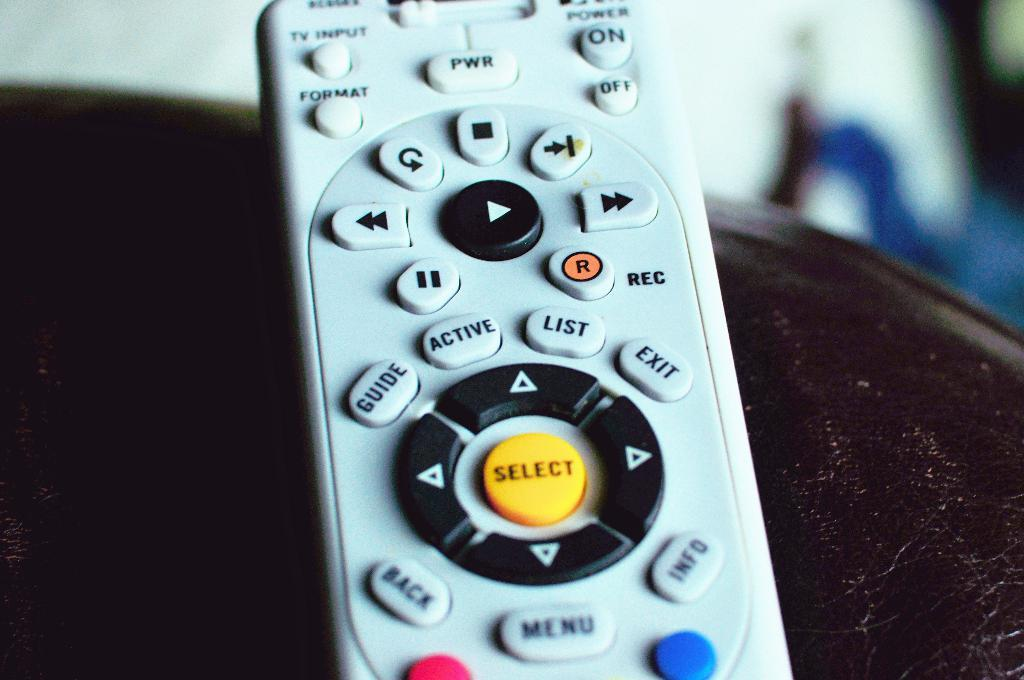<image>
Describe the image concisely. A close up of a remote control with an orange select button. 